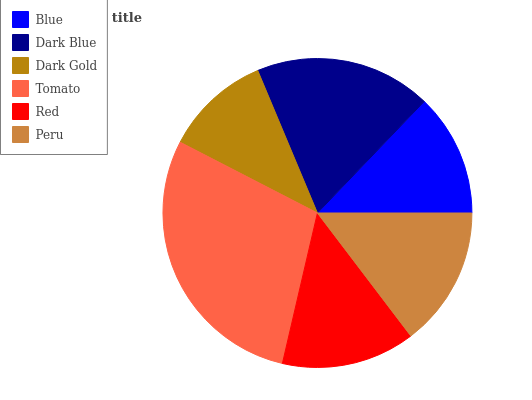Is Dark Gold the minimum?
Answer yes or no. Yes. Is Tomato the maximum?
Answer yes or no. Yes. Is Dark Blue the minimum?
Answer yes or no. No. Is Dark Blue the maximum?
Answer yes or no. No. Is Dark Blue greater than Blue?
Answer yes or no. Yes. Is Blue less than Dark Blue?
Answer yes or no. Yes. Is Blue greater than Dark Blue?
Answer yes or no. No. Is Dark Blue less than Blue?
Answer yes or no. No. Is Peru the high median?
Answer yes or no. Yes. Is Red the low median?
Answer yes or no. Yes. Is Red the high median?
Answer yes or no. No. Is Blue the low median?
Answer yes or no. No. 